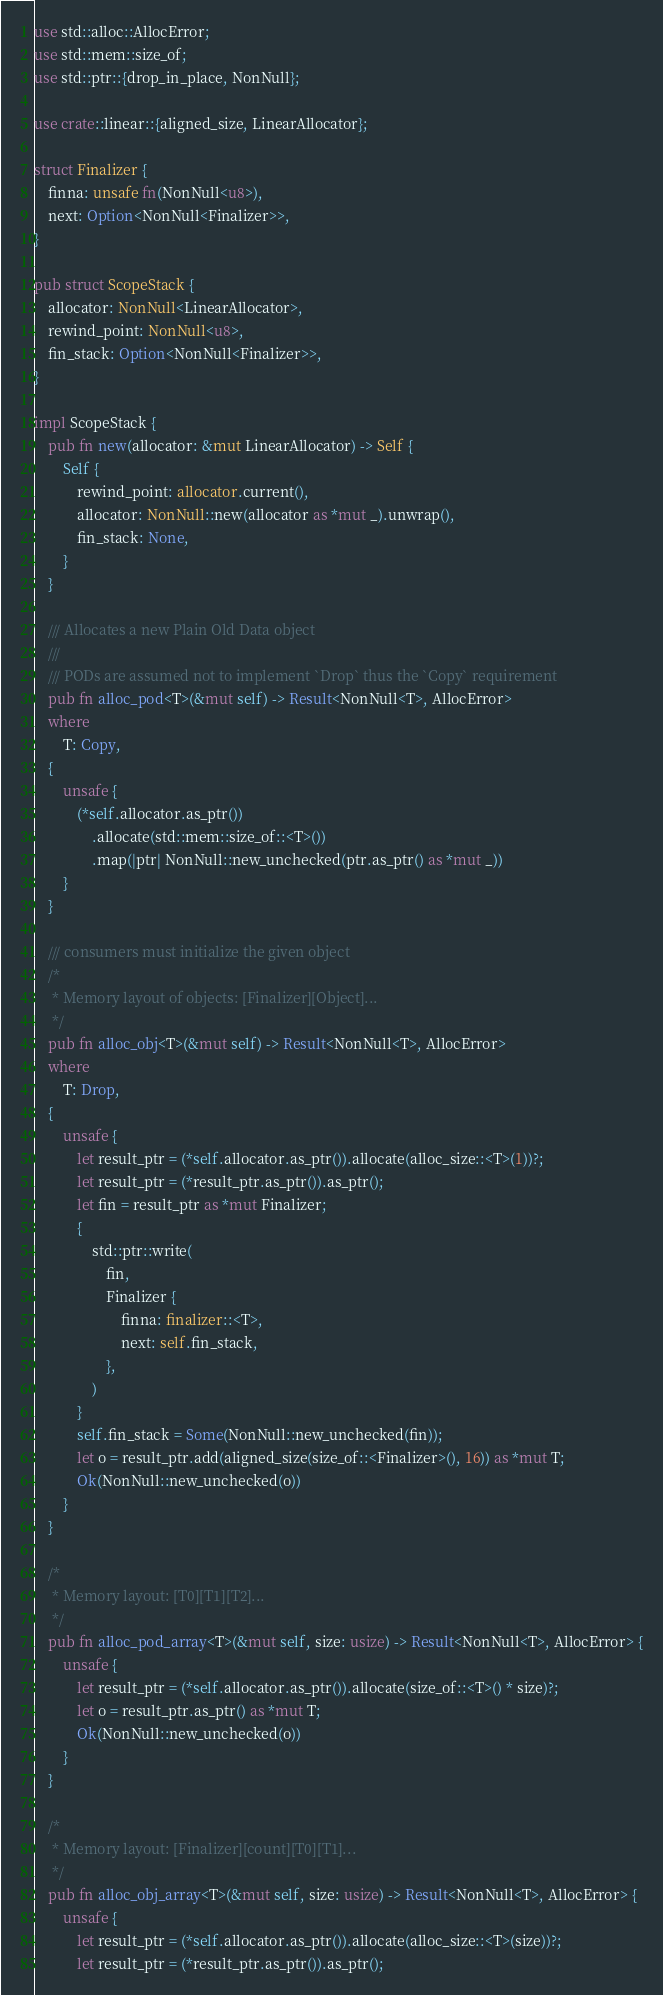Convert code to text. <code><loc_0><loc_0><loc_500><loc_500><_Rust_>use std::alloc::AllocError;
use std::mem::size_of;
use std::ptr::{drop_in_place, NonNull};

use crate::linear::{aligned_size, LinearAllocator};

struct Finalizer {
    finna: unsafe fn(NonNull<u8>),
    next: Option<NonNull<Finalizer>>,
}

pub struct ScopeStack {
    allocator: NonNull<LinearAllocator>,
    rewind_point: NonNull<u8>,
    fin_stack: Option<NonNull<Finalizer>>,
}

impl ScopeStack {
    pub fn new(allocator: &mut LinearAllocator) -> Self {
        Self {
            rewind_point: allocator.current(),
            allocator: NonNull::new(allocator as *mut _).unwrap(),
            fin_stack: None,
        }
    }

    /// Allocates a new Plain Old Data object
    ///
    /// PODs are assumed not to implement `Drop` thus the `Copy` requirement
    pub fn alloc_pod<T>(&mut self) -> Result<NonNull<T>, AllocError>
    where
        T: Copy,
    {
        unsafe {
            (*self.allocator.as_ptr())
                .allocate(std::mem::size_of::<T>())
                .map(|ptr| NonNull::new_unchecked(ptr.as_ptr() as *mut _))
        }
    }

    /// consumers must initialize the given object
    /*
     * Memory layout of objects: [Finalizer][Object]...
     */
    pub fn alloc_obj<T>(&mut self) -> Result<NonNull<T>, AllocError>
    where
        T: Drop,
    {
        unsafe {
            let result_ptr = (*self.allocator.as_ptr()).allocate(alloc_size::<T>(1))?;
            let result_ptr = (*result_ptr.as_ptr()).as_ptr();
            let fin = result_ptr as *mut Finalizer;
            {
                std::ptr::write(
                    fin,
                    Finalizer {
                        finna: finalizer::<T>,
                        next: self.fin_stack,
                    },
                )
            }
            self.fin_stack = Some(NonNull::new_unchecked(fin));
            let o = result_ptr.add(aligned_size(size_of::<Finalizer>(), 16)) as *mut T;
            Ok(NonNull::new_unchecked(o))
        }
    }

    /*
     * Memory layout: [T0][T1][T2]...
     */
    pub fn alloc_pod_array<T>(&mut self, size: usize) -> Result<NonNull<T>, AllocError> {
        unsafe {
            let result_ptr = (*self.allocator.as_ptr()).allocate(size_of::<T>() * size)?;
            let o = result_ptr.as_ptr() as *mut T;
            Ok(NonNull::new_unchecked(o))
        }
    }

    /*
     * Memory layout: [Finalizer][count][T0][T1]...
     */
    pub fn alloc_obj_array<T>(&mut self, size: usize) -> Result<NonNull<T>, AllocError> {
        unsafe {
            let result_ptr = (*self.allocator.as_ptr()).allocate(alloc_size::<T>(size))?;
            let result_ptr = (*result_ptr.as_ptr()).as_ptr();</code> 